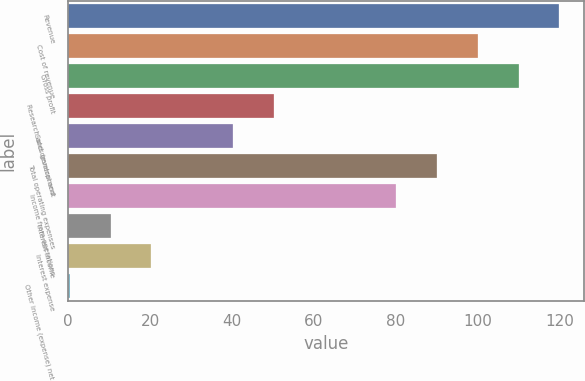Convert chart to OTSL. <chart><loc_0><loc_0><loc_500><loc_500><bar_chart><fcel>Revenue<fcel>Cost of revenue<fcel>Gross profit<fcel>Research and development<fcel>Sales general and<fcel>Total operating expenses<fcel>Income from operations<fcel>Interest income<fcel>Interest expense<fcel>Other income (expense) net<nl><fcel>119.92<fcel>100<fcel>109.96<fcel>50.2<fcel>40.24<fcel>90.04<fcel>80.08<fcel>10.36<fcel>20.32<fcel>0.4<nl></chart> 